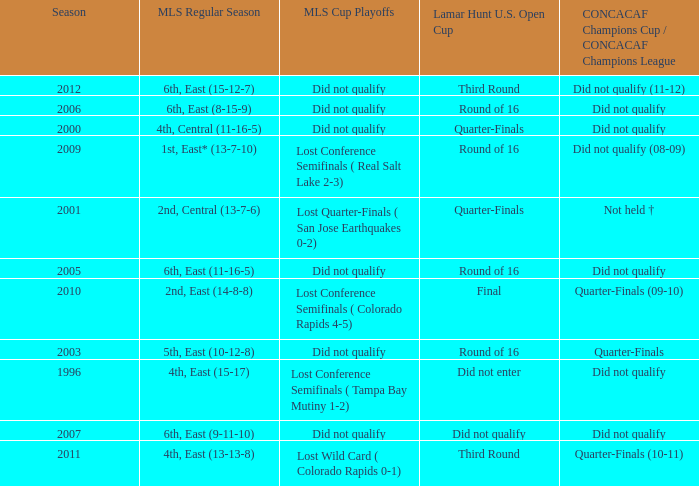What was the season when mls regular season was 6th, east (9-11-10)? 2007.0. 